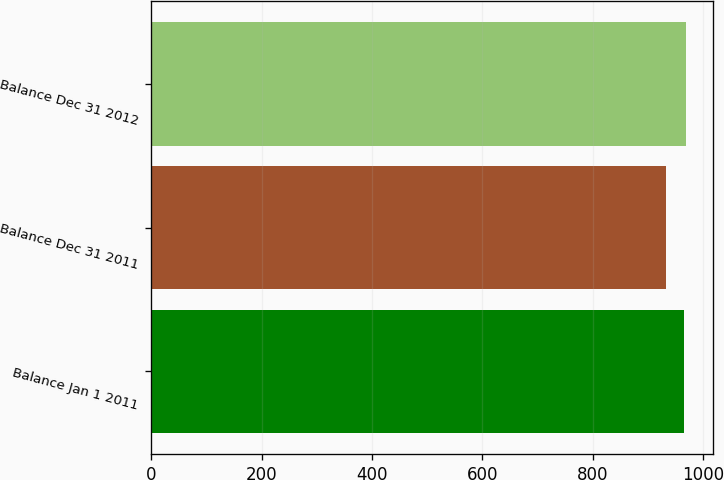<chart> <loc_0><loc_0><loc_500><loc_500><bar_chart><fcel>Balance Jan 1 2011<fcel>Balance Dec 31 2011<fcel>Balance Dec 31 2012<nl><fcel>966<fcel>933<fcel>970<nl></chart> 